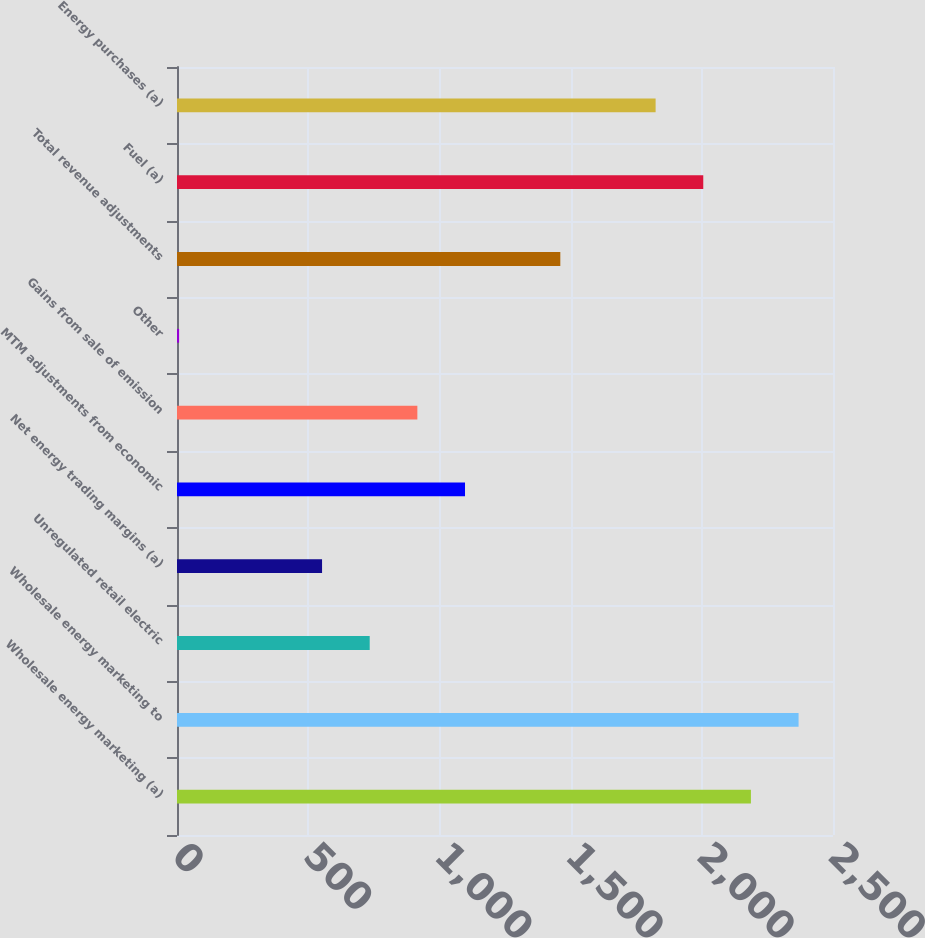Convert chart to OTSL. <chart><loc_0><loc_0><loc_500><loc_500><bar_chart><fcel>Wholesale energy marketing (a)<fcel>Wholesale energy marketing to<fcel>Unregulated retail electric<fcel>Net energy trading margins (a)<fcel>MTM adjustments from economic<fcel>Gains from sale of emission<fcel>Other<fcel>Total revenue adjustments<fcel>Fuel (a)<fcel>Energy purchases (a)<nl><fcel>2187.2<fcel>2368.8<fcel>734.4<fcel>552.8<fcel>1097.6<fcel>916<fcel>8<fcel>1460.8<fcel>2005.6<fcel>1824<nl></chart> 